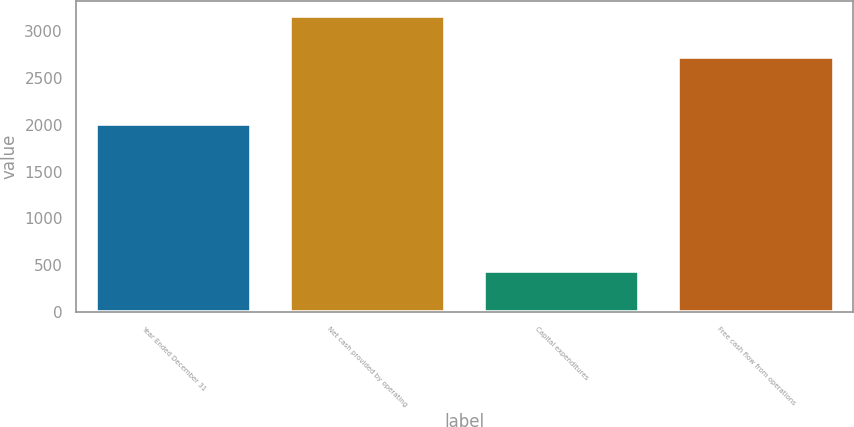<chart> <loc_0><loc_0><loc_500><loc_500><bar_chart><fcel>Year Ended December 31<fcel>Net cash provided by operating<fcel>Capital expenditures<fcel>Free cash flow from operations<nl><fcel>2013<fcel>3159<fcel>436<fcel>2723<nl></chart> 